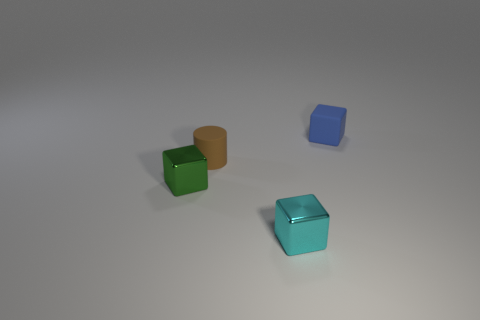Are there any tiny blue objects that have the same material as the tiny cylinder?
Offer a terse response. Yes. There is a metallic object on the left side of the tiny cyan metal block; is there a tiny metallic block that is in front of it?
Give a very brief answer. Yes. Are there any things in front of the metal cube in front of the small metallic thing on the left side of the tiny cyan metallic cube?
Keep it short and to the point. No. There is a cube left of the tiny brown cylinder; what is its material?
Offer a terse response. Metal. The small cube that is both on the right side of the tiny green thing and behind the cyan shiny cube is what color?
Give a very brief answer. Blue. What shape is the other thing that is made of the same material as the tiny blue object?
Your answer should be compact. Cylinder. What number of matte objects are right of the cylinder and in front of the tiny rubber block?
Offer a very short reply. 0. There is a tiny metal object in front of the green cube; is it the same shape as the object that is to the right of the tiny cyan metal thing?
Ensure brevity in your answer.  Yes. What number of other things are there of the same shape as the tiny cyan object?
Provide a short and direct response. 2. Do the tiny blue block on the right side of the tiny green cube and the cyan object have the same material?
Offer a terse response. No. 